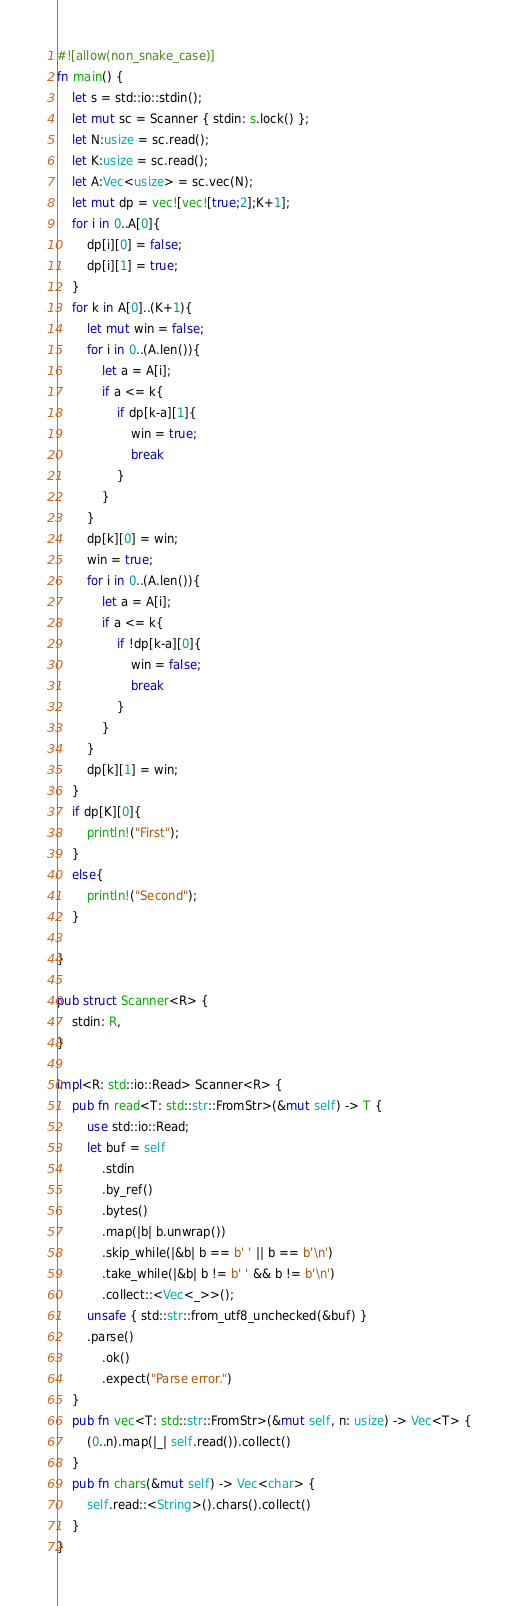Convert code to text. <code><loc_0><loc_0><loc_500><loc_500><_Rust_>#![allow(non_snake_case)]
fn main() {
    let s = std::io::stdin();
    let mut sc = Scanner { stdin: s.lock() };
    let N:usize = sc.read();
    let K:usize = sc.read();
    let A:Vec<usize> = sc.vec(N);
    let mut dp = vec![vec![true;2];K+1];
    for i in 0..A[0]{
        dp[i][0] = false;
        dp[i][1] = true;
    }
    for k in A[0]..(K+1){
        let mut win = false;
        for i in 0..(A.len()){
            let a = A[i];
            if a <= k{
                if dp[k-a][1]{
                    win = true;
                    break
                }
            }
        }
        dp[k][0] = win;
        win = true;
        for i in 0..(A.len()){
            let a = A[i];
            if a <= k{
                if !dp[k-a][0]{
                    win = false;
                    break
                }
            }
        }
        dp[k][1] = win;
    }
    if dp[K][0]{
        println!("First");
    }
    else{
        println!("Second");
    }

}

pub struct Scanner<R> {
    stdin: R,
}

impl<R: std::io::Read> Scanner<R> {
    pub fn read<T: std::str::FromStr>(&mut self) -> T {
        use std::io::Read;
        let buf = self
            .stdin
            .by_ref()
            .bytes()
            .map(|b| b.unwrap())
            .skip_while(|&b| b == b' ' || b == b'\n')
            .take_while(|&b| b != b' ' && b != b'\n')
            .collect::<Vec<_>>();
        unsafe { std::str::from_utf8_unchecked(&buf) }
        .parse()
            .ok()
            .expect("Parse error.")
    }
    pub fn vec<T: std::str::FromStr>(&mut self, n: usize) -> Vec<T> {
        (0..n).map(|_| self.read()).collect()
    }
    pub fn chars(&mut self) -> Vec<char> {
        self.read::<String>().chars().collect()
    }
}


</code> 